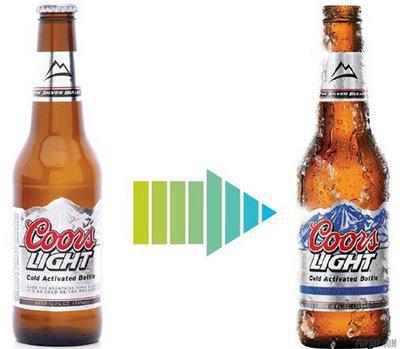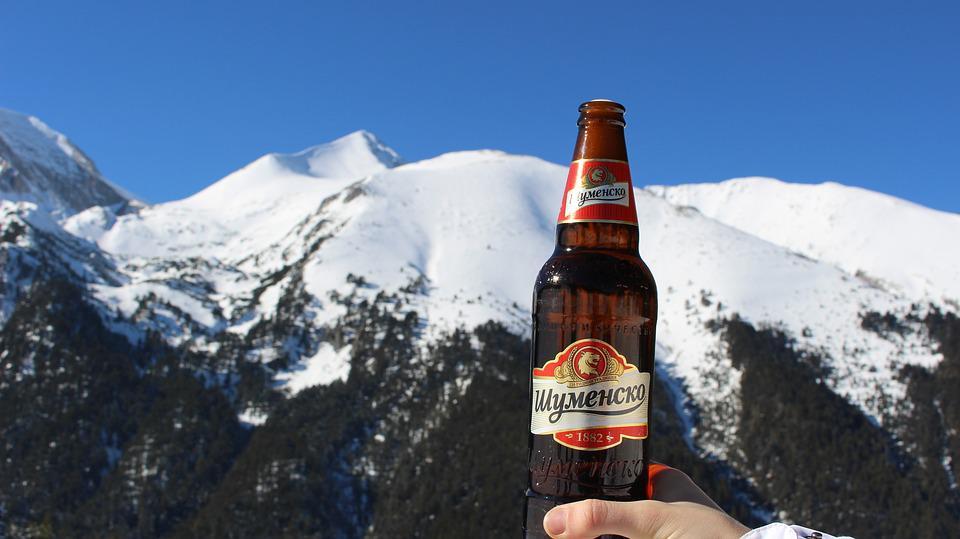The first image is the image on the left, the second image is the image on the right. Examine the images to the left and right. Is the description "All beverage bottles have labels around both the body and neck of the bottle." accurate? Answer yes or no. Yes. The first image is the image on the left, the second image is the image on the right. Analyze the images presented: Is the assertion "At least one beer bottle is posed in front of a beach sunset, in one image." valid? Answer yes or no. No. 